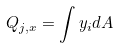Convert formula to latex. <formula><loc_0><loc_0><loc_500><loc_500>Q _ { j , x } = \int y _ { i } d A</formula> 